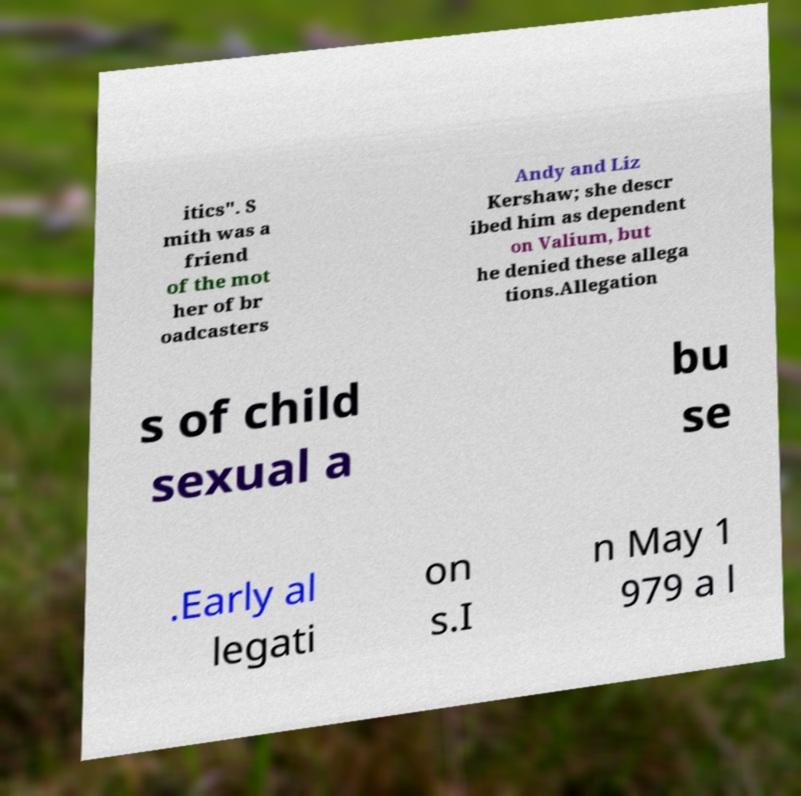Could you extract and type out the text from this image? itics". S mith was a friend of the mot her of br oadcasters Andy and Liz Kershaw; she descr ibed him as dependent on Valium, but he denied these allega tions.Allegation s of child sexual a bu se .Early al legati on s.I n May 1 979 a l 